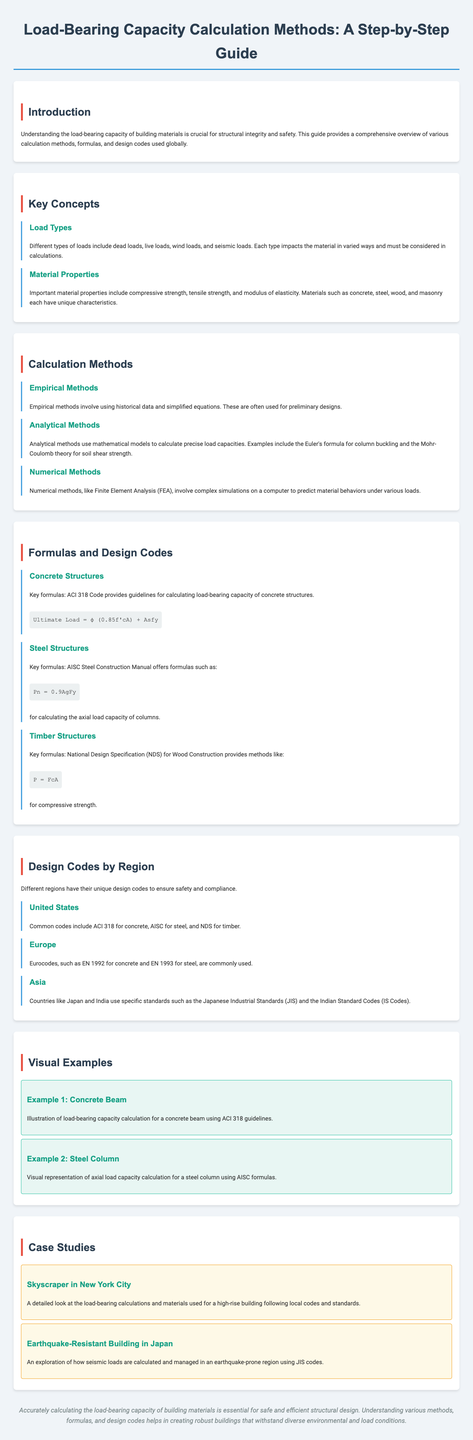What is the title of the guide? The title is located in the header of the document, prominently displayed.
Answer: Load-Bearing Capacity Calculation Methods: A Step-by-Step Guide What are the different types of loads mentioned? The document lists various types of loads that need to be considered in calculations.
Answer: Dead loads, live loads, wind loads, seismic loads Which code provides guidelines for concrete structures? The document references a specific code for concrete load-bearing capacity calculations.
Answer: ACI 318 What formula is used for timber structures? The document includes a specific formula used to calculate timber structures' load-bearing capacity.
Answer: P = FcA What design code is commonly used in Europe? The document indicates a specific set of codes commonly adopted in Europe.
Answer: Eurocodes How does the document categorize its sections? The sections are arranged according to key themes in load-bearing capacity calculations.
Answer: Introduction, Key Concepts, Calculation Methods, Formulas and Design Codes, Design Codes by Region, Visual Examples, Case Studies, Conclusion What structural example is given for a steel structure? The document mentions a specific type of steel structure in its examples section.
Answer: Steel Column What region uses the Japanese Industrial Standards? The document specifies which countries utilize these design standards.
Answer: Asia Which method involves complex simulations? The document describes a particular method that utilizes simulations for calculations.
Answer: Numerical Methods What city is featured in a case study? The document highlights a specific city within one of its case studies related to skyscrapers.
Answer: New York City 